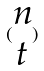<formula> <loc_0><loc_0><loc_500><loc_500>( \begin{matrix} n \\ t \end{matrix} )</formula> 